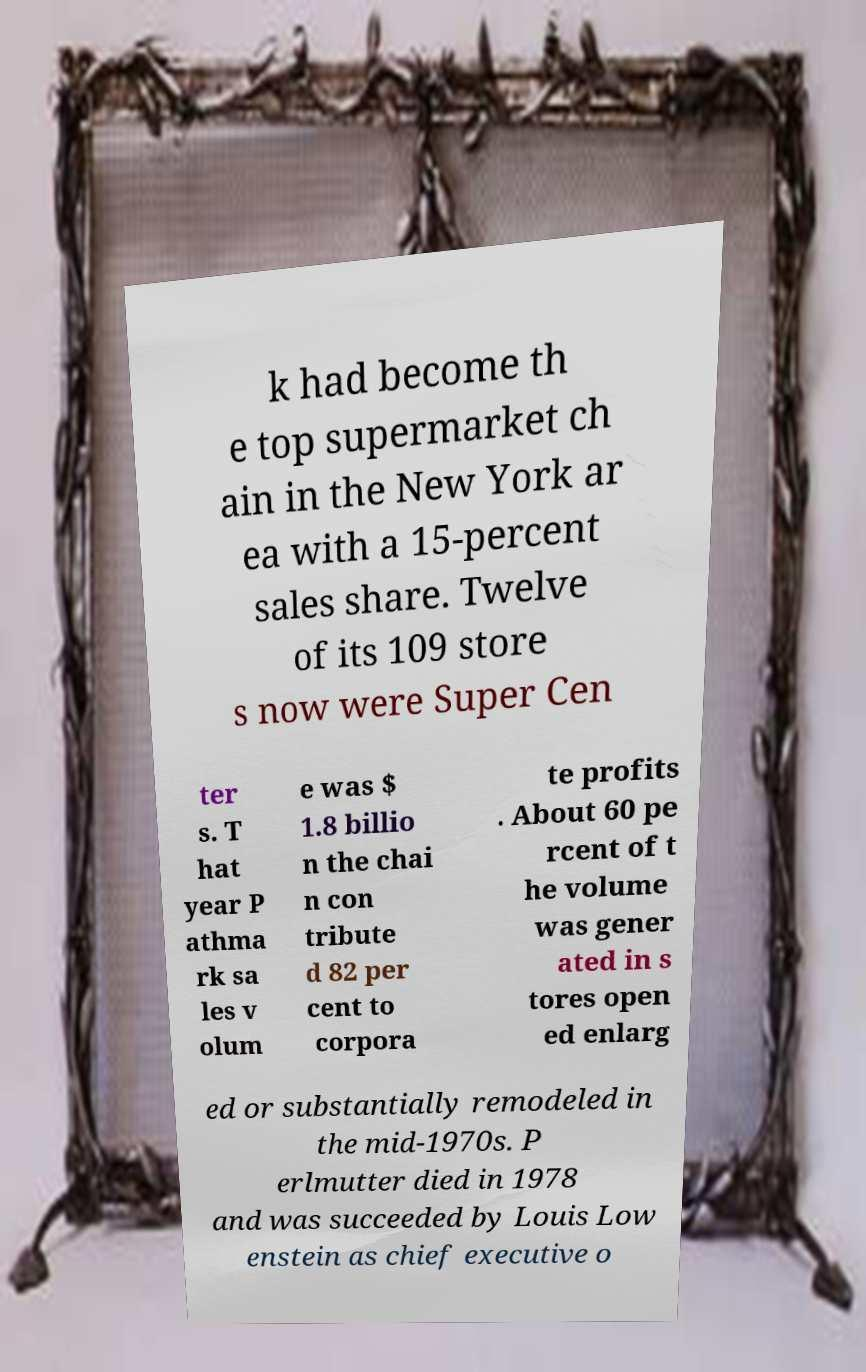For documentation purposes, I need the text within this image transcribed. Could you provide that? k had become th e top supermarket ch ain in the New York ar ea with a 15-percent sales share. Twelve of its 109 store s now were Super Cen ter s. T hat year P athma rk sa les v olum e was $ 1.8 billio n the chai n con tribute d 82 per cent to corpora te profits . About 60 pe rcent of t he volume was gener ated in s tores open ed enlarg ed or substantially remodeled in the mid-1970s. P erlmutter died in 1978 and was succeeded by Louis Low enstein as chief executive o 